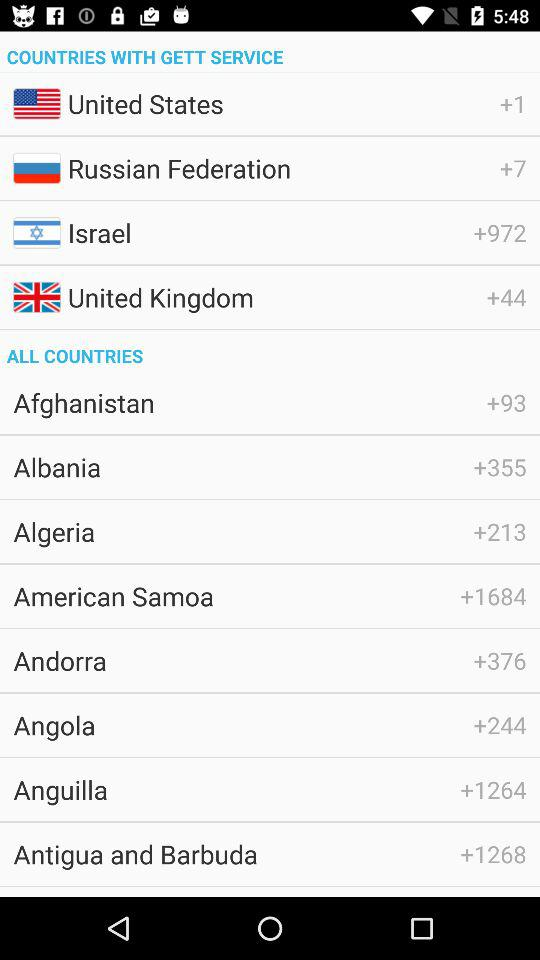Which country has the country code +244? The country is Angola. 